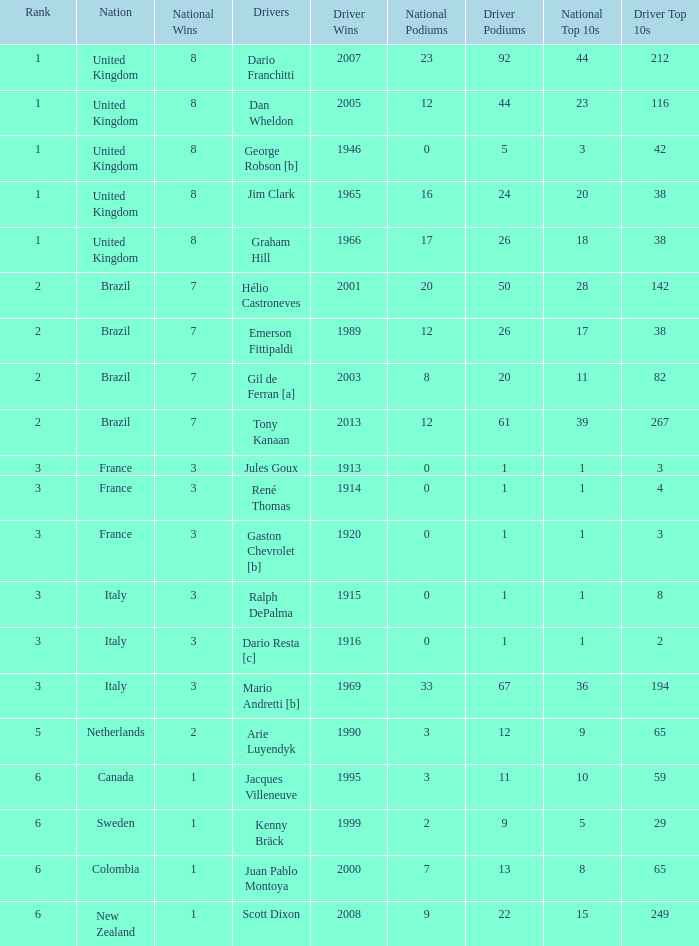What is the average number of wins of drivers from Sweden? 1999.0. 